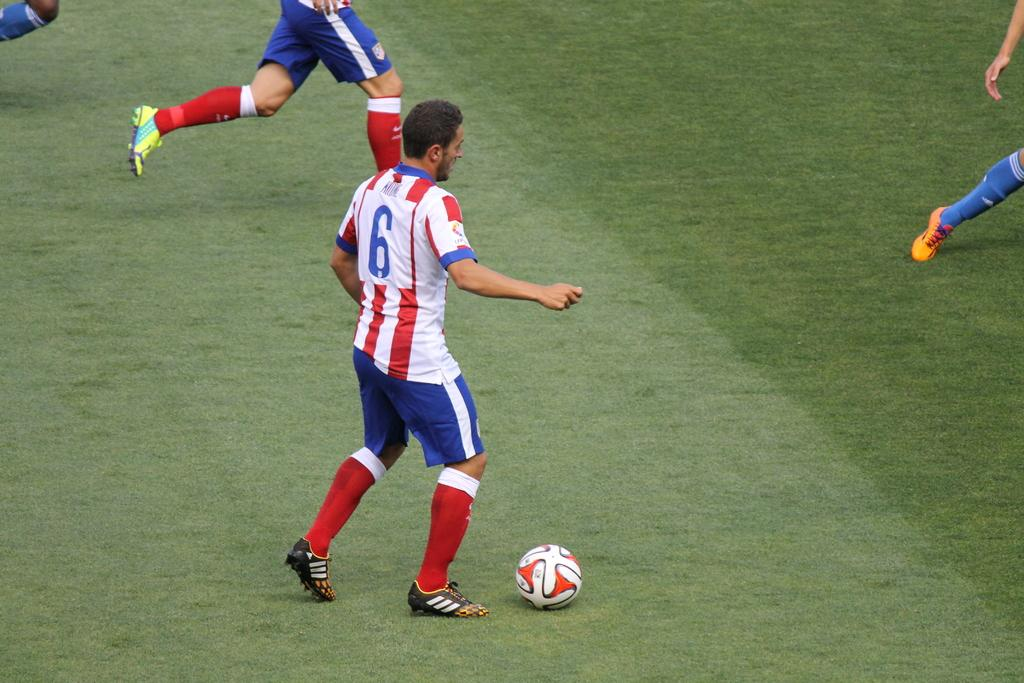<image>
Share a concise interpretation of the image provided. The number 6 player on the soccer team with red and white striped shirts has the ball and is preparing to make his move. 